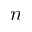<formula> <loc_0><loc_0><loc_500><loc_500>n</formula> 